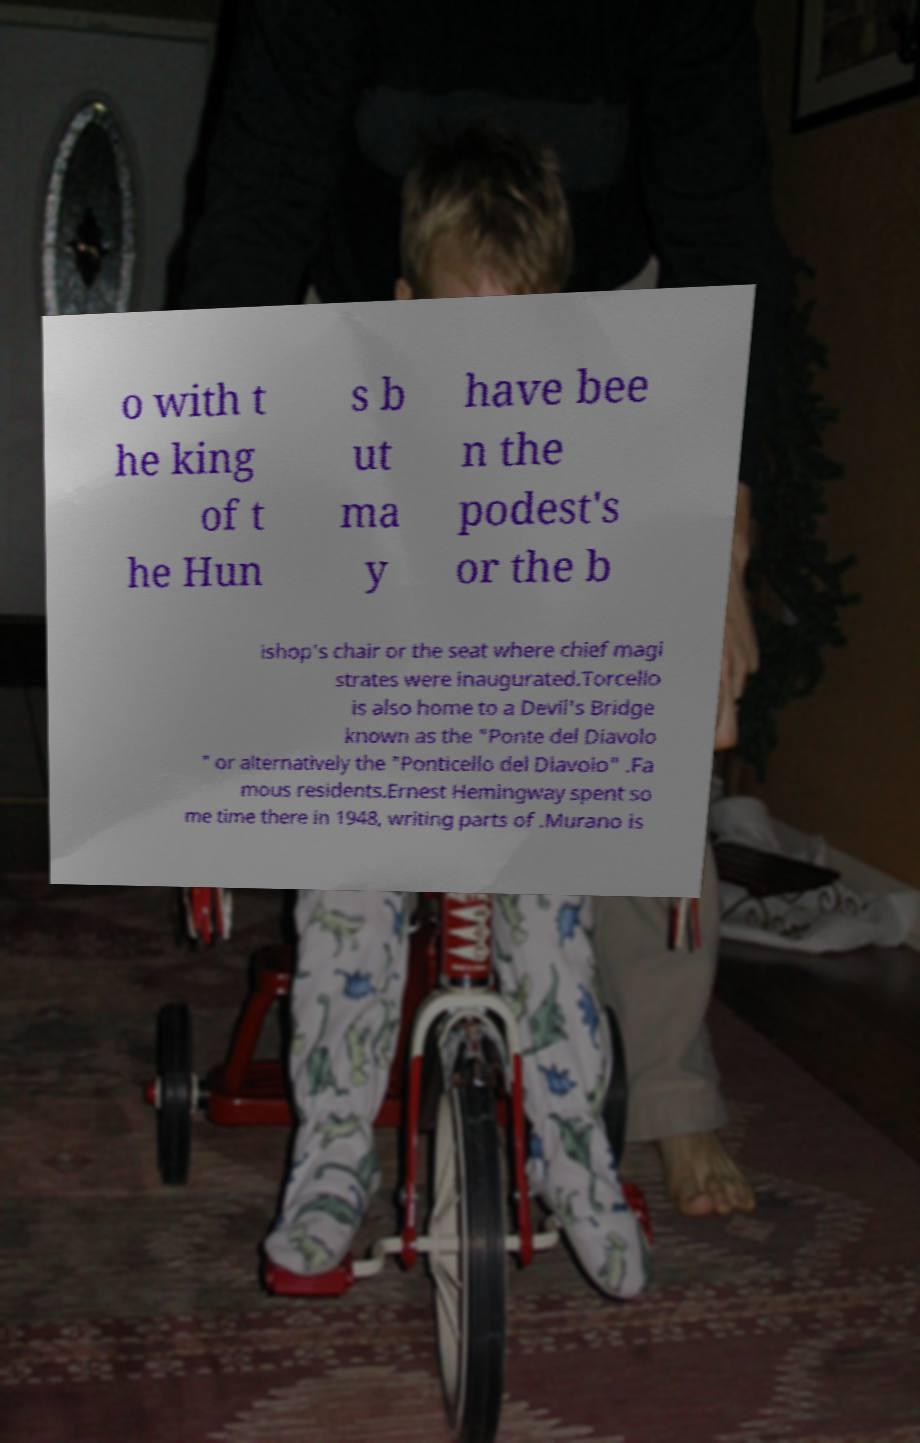Please identify and transcribe the text found in this image. o with t he king of t he Hun s b ut ma y have bee n the podest's or the b ishop's chair or the seat where chief magi strates were inaugurated.Torcello is also home to a Devil's Bridge known as the "Ponte del Diavolo " or alternatively the "Ponticello del Diavolo" .Fa mous residents.Ernest Hemingway spent so me time there in 1948, writing parts of .Murano is 